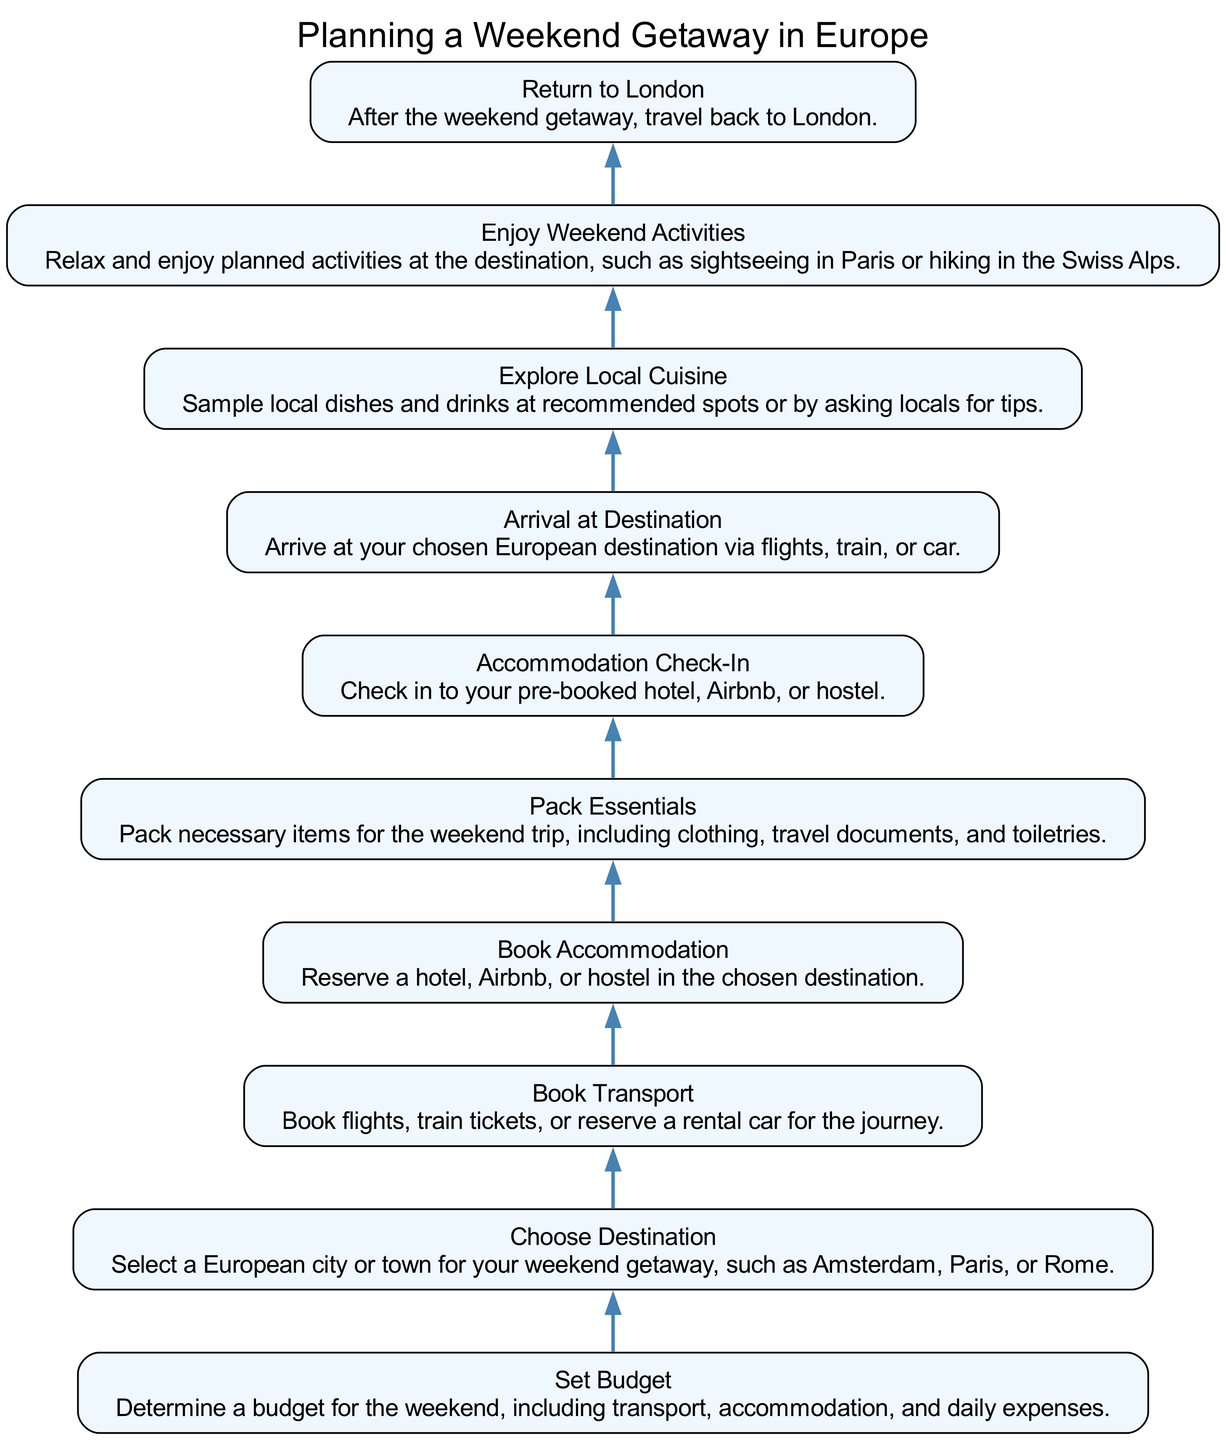What is the first step in the diagram? The first step in the diagram is "Set Budget," which has no dependencies and starts the planning process.
Answer: Set Budget How many nodes are there in the diagram? By counting each unique task in the diagram, there are ten nodes present.
Answer: 10 What task follows "Book Transport"? The task that follows "Book Transport" is "Choose Destination," as indicated by the flow from one task to the next in the diagram.
Answer: Choose Destination Which task requires "Arrival at Destination" to complete? The task that requires "Arrival at Destination" to complete is "Explore Local Cuisine," as it depends on the arrival at the chosen destination.
Answer: Explore Local Cuisine What is the last task to be completed in the sequence? The last task to be completed in the sequence is "Return to London," coming after all the other tasks have been completed.
Answer: Return to London How many dependencies does "Pack Essentials" have? "Pack Essentials" has one dependency, which is "Book Accommodation," that must be completed before packing can occur.
Answer: 1 If "Choose Destination" has been completed, what must be done next? After completing "Choose Destination," the next task is "Book Transport," which is directly dependent on it according to the diagram flow.
Answer: Book Transport Which task links "Explore Local Cuisine" and "Enjoy Weekend Activities"? The task that links "Explore Local Cuisine" and "Enjoy Weekend Activities" is a direct flow, where the completion of "Explore Local Cuisine" allows for "Enjoy Weekend Activities" to begin.
Answer: Explore Local Cuisine What type of diagram is displayed here? The diagram displayed is a flowchart of an executable function, with tasks represented as nodes and dependencies as directed edges showing the sequence of actions to be taken.
Answer: Flowchart 